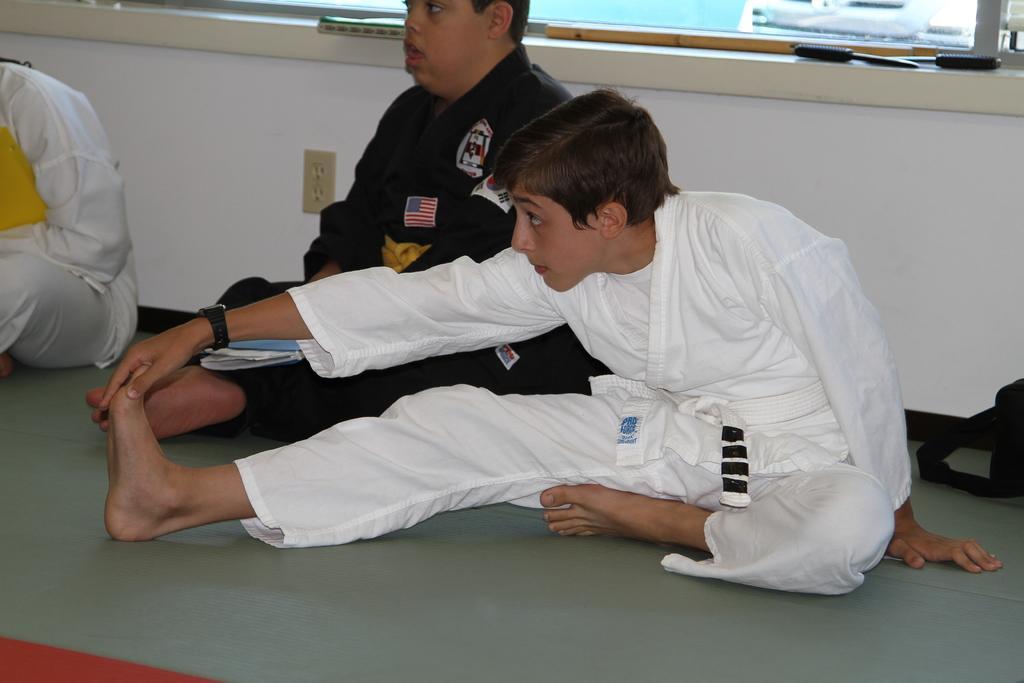In one or two sentences, can you explain what this image depicts? In this picture we can see there are three people sitting on the path and on the right side of the man, it looks like a bag. Behind the people there are some objects on the platform. 